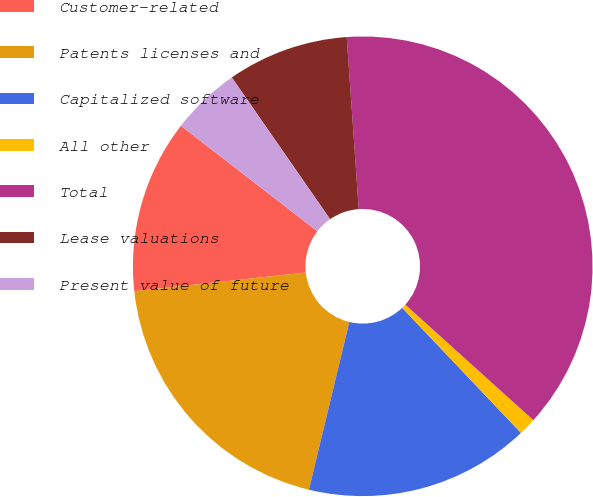Convert chart. <chart><loc_0><loc_0><loc_500><loc_500><pie_chart><fcel>Customer-related<fcel>Patents licenses and<fcel>Capitalized software<fcel>All other<fcel>Total<fcel>Lease valuations<fcel>Present value of future<nl><fcel>12.2%<fcel>19.51%<fcel>15.85%<fcel>1.23%<fcel>37.79%<fcel>8.54%<fcel>4.88%<nl></chart> 